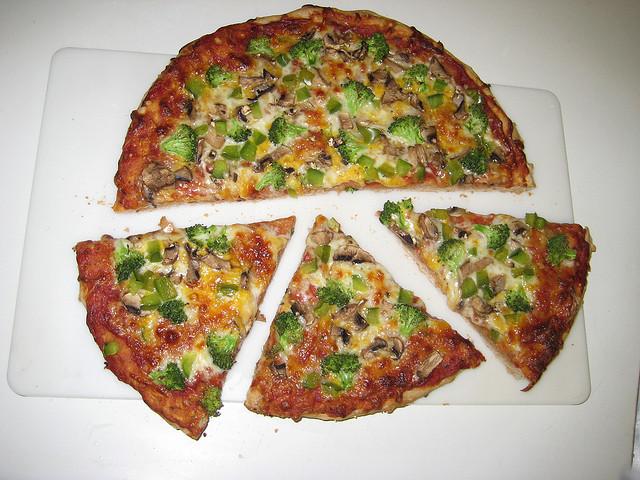How many slices of pizza are there?
Keep it brief. 4. What is the pizza sitting on?
Write a very short answer. Cutting board. Has anyone started to eat the pizza?
Give a very brief answer. No. 